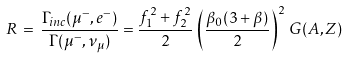Convert formula to latex. <formula><loc_0><loc_0><loc_500><loc_500>R \, = \, \frac { \Gamma _ { i n c } ( \mu ^ { - } , e ^ { - } ) } { \Gamma ( \mu ^ { - } , \nu _ { \mu } ) } = \frac { f ^ { 2 } _ { 1 } + f ^ { 2 } _ { 2 } } { 2 } \, \left ( \frac { \beta _ { 0 } ( 3 + \beta ) } { 2 } \right ) ^ { 2 } \, G ( A , Z )</formula> 